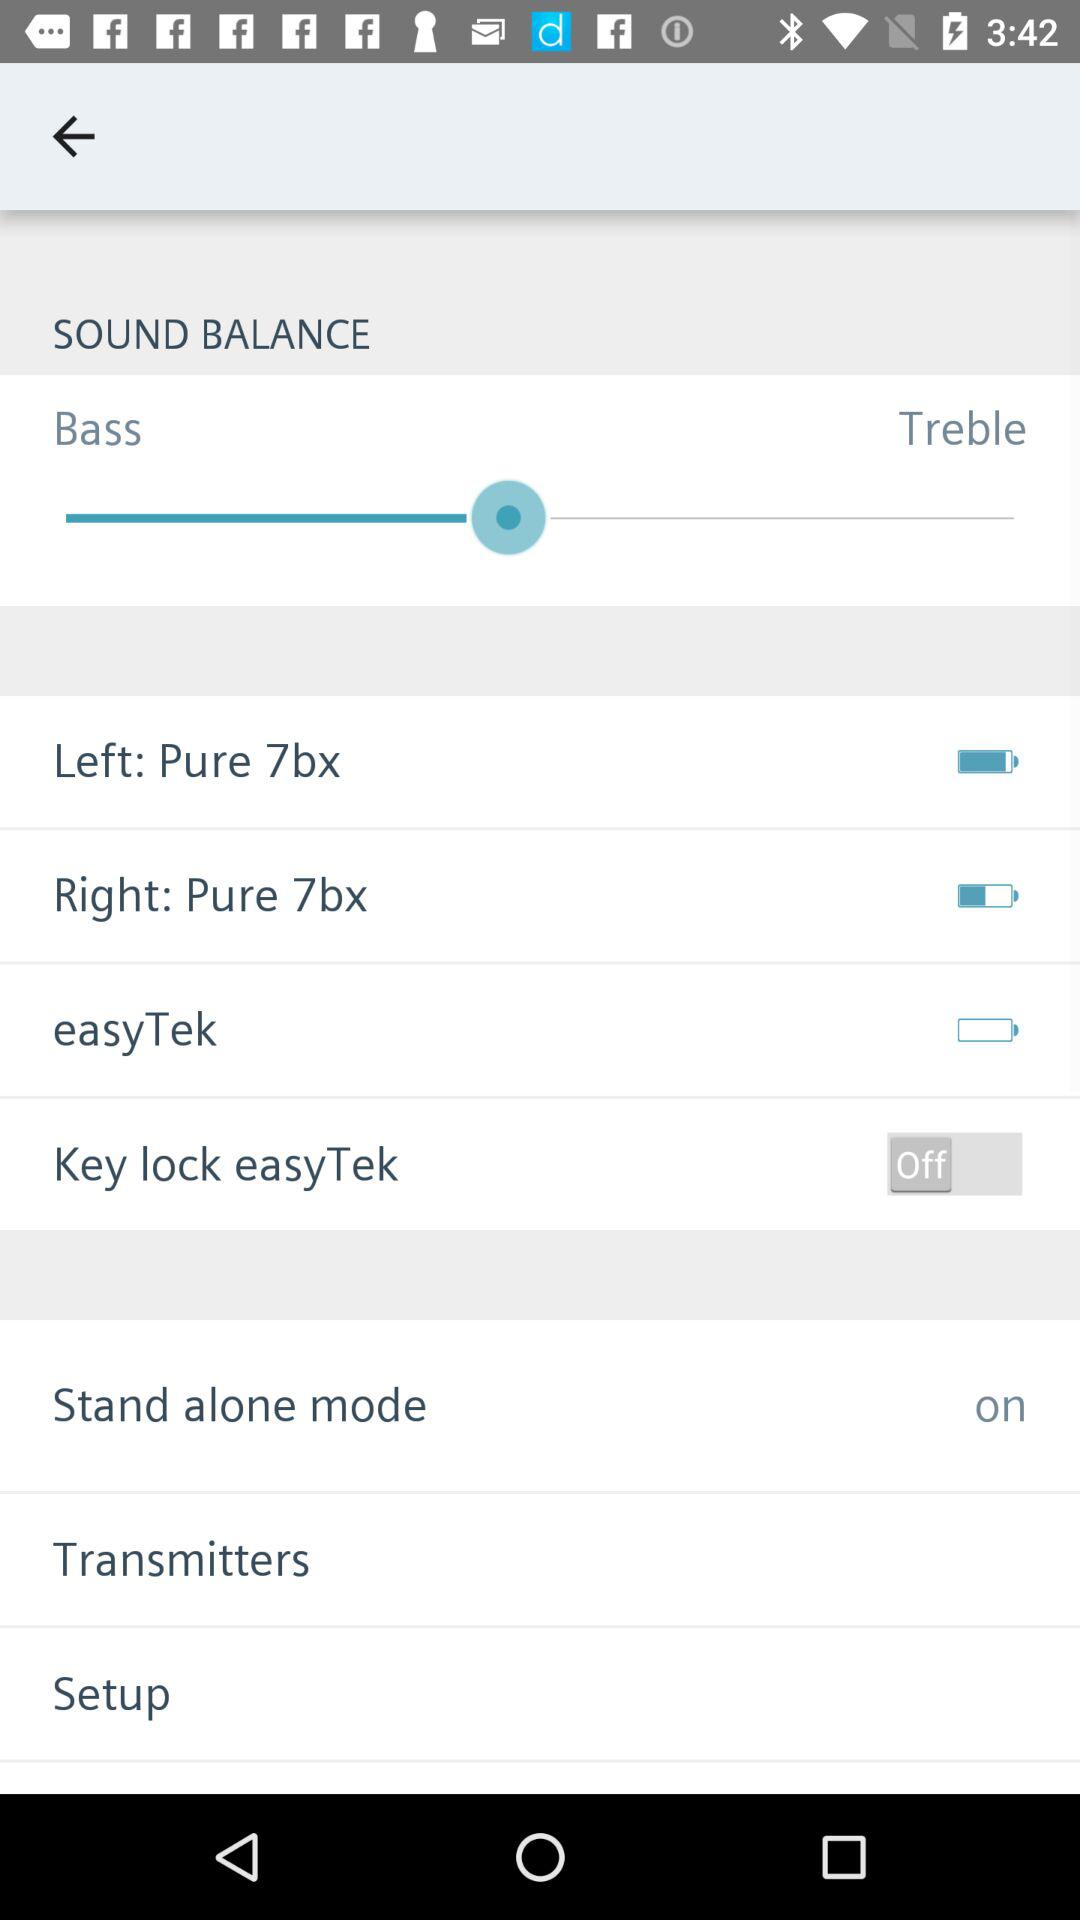Which two options are given for sound balance? The two options given for sound balance are "Bass" and "Treble". 